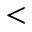Convert formula to latex. <formula><loc_0><loc_0><loc_500><loc_500><</formula> 